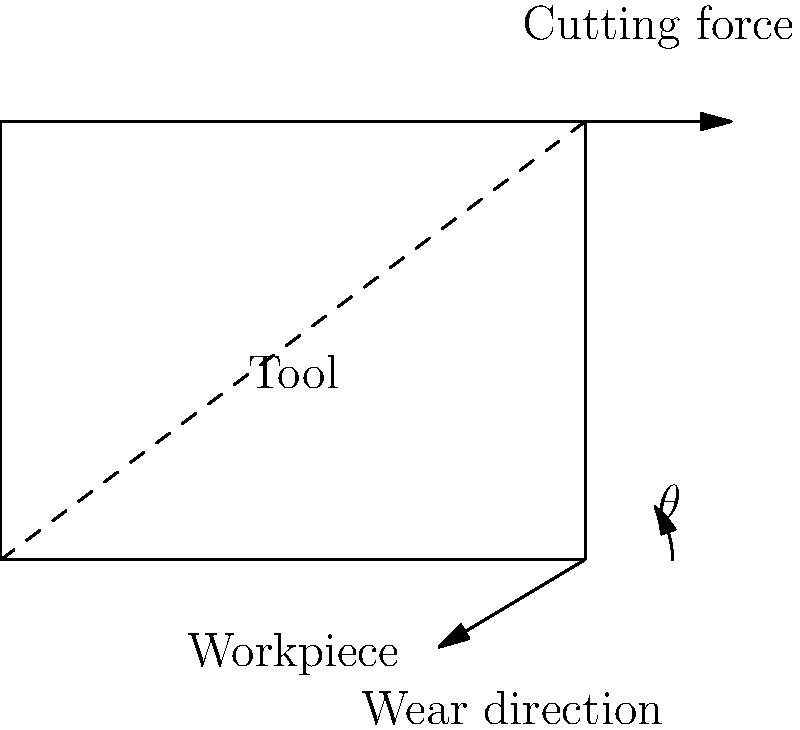As a machinist aiming to optimize your lathe operation, you need to determine the best tool angle $\theta$ for cutting steel. Given that the optimal angle balances cutting speed with tool wear, and considering that the cutting force is 1000 N and the coefficient of friction between the tool and workpiece is 0.3, what is the optimal tool angle $\theta$ (in degrees) that will minimize wear while maximizing cutting speed? To find the optimal tool angle, we need to balance the forces acting on the tool to minimize wear and maximize cutting efficiency. Here's how we can approach this:

1) The force of friction is given by $F_f = \mu N$, where $\mu$ is the coefficient of friction and $N$ is the normal force.

2) The cutting force $F_c$ can be decomposed into two components:
   - Normal force: $N = F_c \sin \theta$
   - Tangential force: $F_t = F_c \cos \theta$

3) The force of friction is then:
   $F_f = \mu F_c \sin \theta$

4) For optimal cutting, the tangential force should be equal to the friction force:
   $F_c \cos \theta = \mu F_c \sin \theta$

5) Simplifying this equation:
   $\cos \theta = \mu \sin \theta$
   $\cot \theta = \mu$

6) Therefore, the optimal angle is given by:
   $\theta = \arctan(\frac{1}{\mu})$

7) Plugging in the given coefficient of friction:
   $\theta = \arctan(\frac{1}{0.3})$

8) Calculate the result:
   $\theta \approx 73.3°$

This angle provides the best balance between cutting speed and tool wear, considering the given conditions.
Answer: $73.3°$ 